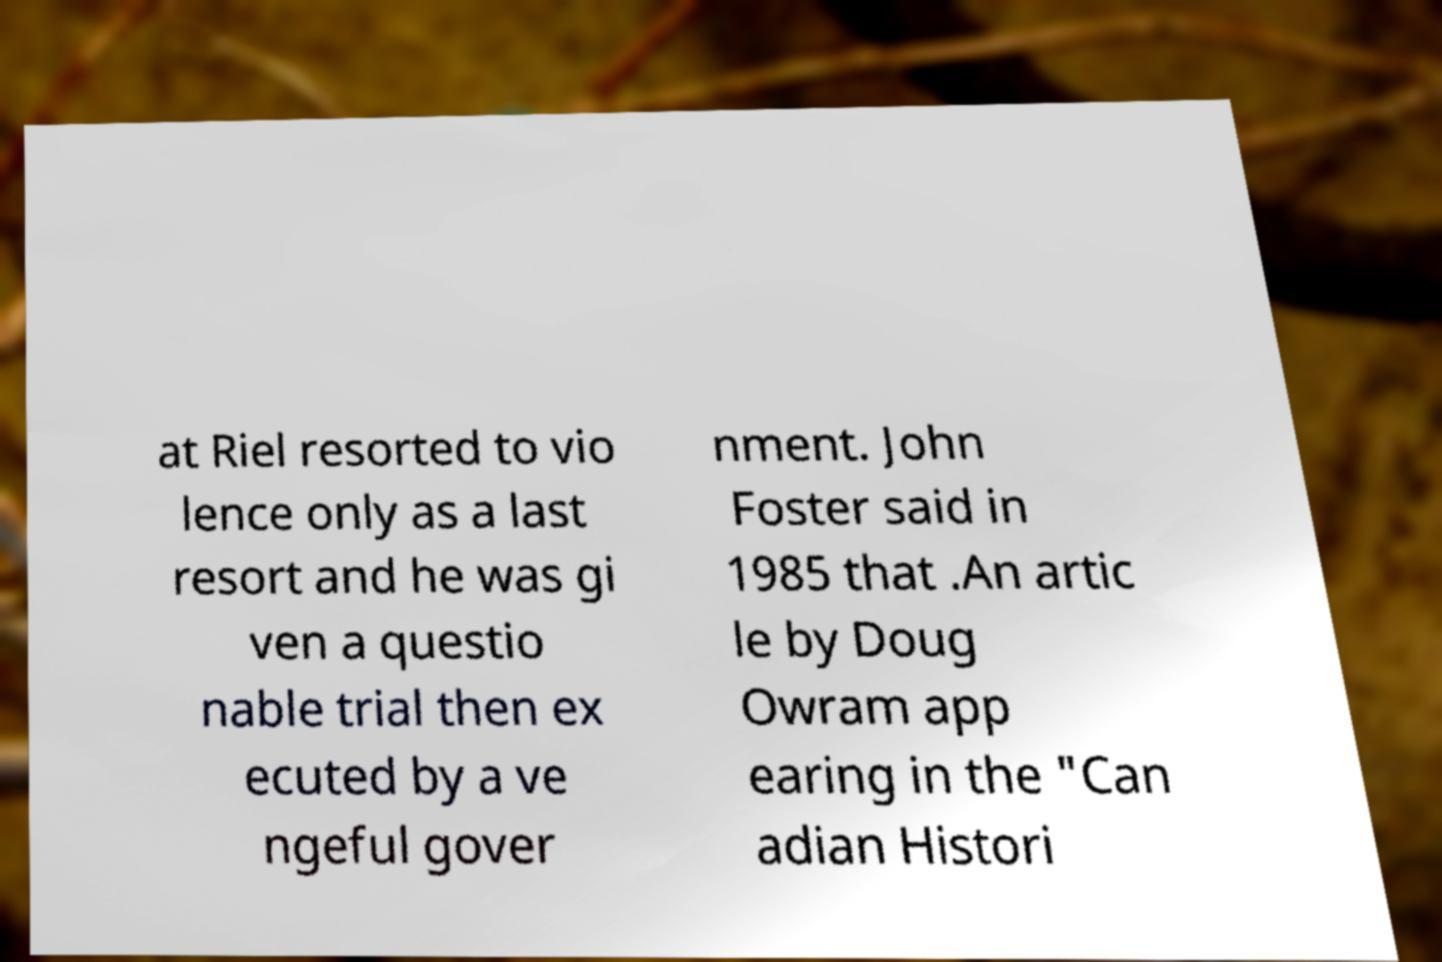I need the written content from this picture converted into text. Can you do that? at Riel resorted to vio lence only as a last resort and he was gi ven a questio nable trial then ex ecuted by a ve ngeful gover nment. John Foster said in 1985 that .An artic le by Doug Owram app earing in the "Can adian Histori 